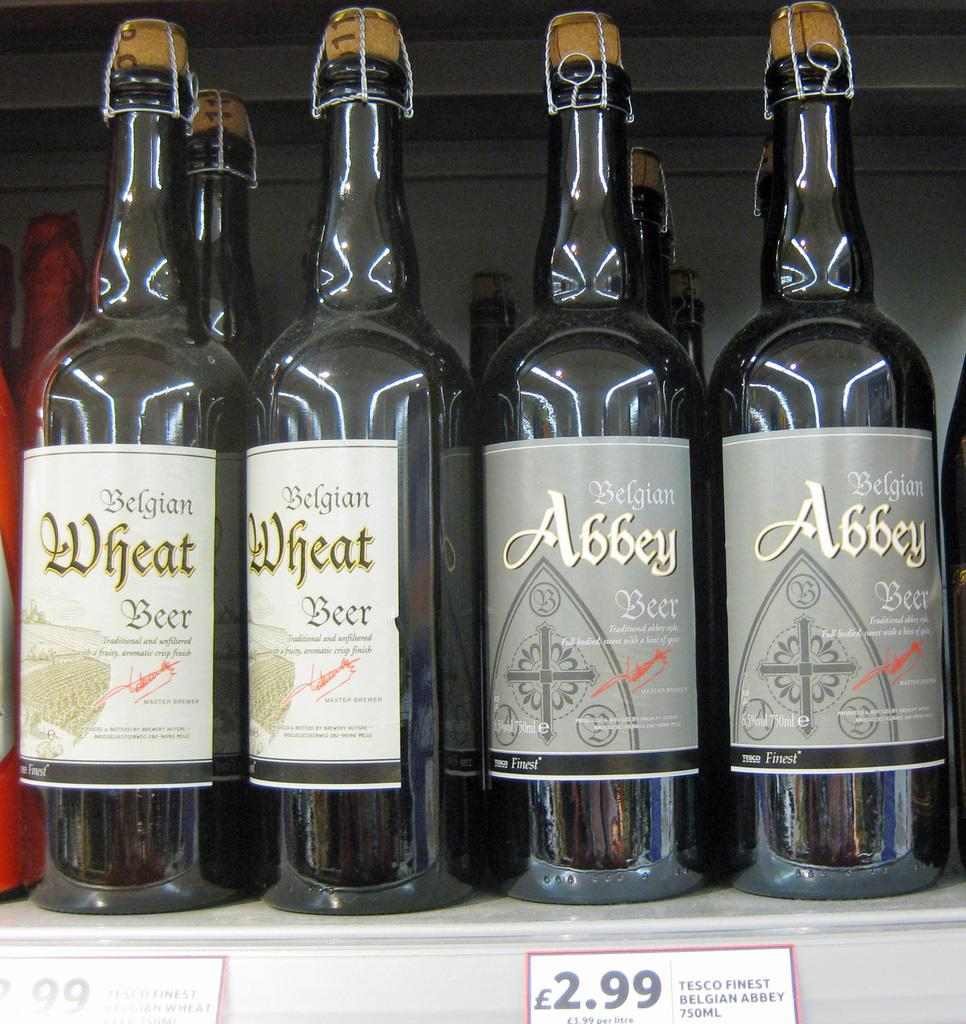<image>
Present a compact description of the photo's key features. Two bottles of Belgian Wheat Beer and two bottles of Abbey Wheat Beer sit on a shelf at a Tesco store. 